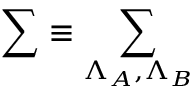<formula> <loc_0><loc_0><loc_500><loc_500>\sum \equiv \sum _ { \Lambda _ { A } , \Lambda _ { B } }</formula> 